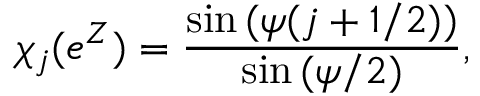Convert formula to latex. <formula><loc_0><loc_0><loc_500><loc_500>\chi _ { j } ( e ^ { Z } ) = { \frac { \sin { ( \psi ( j + 1 / 2 ) ) } } { \sin { ( \psi / 2 ) } } } ,</formula> 